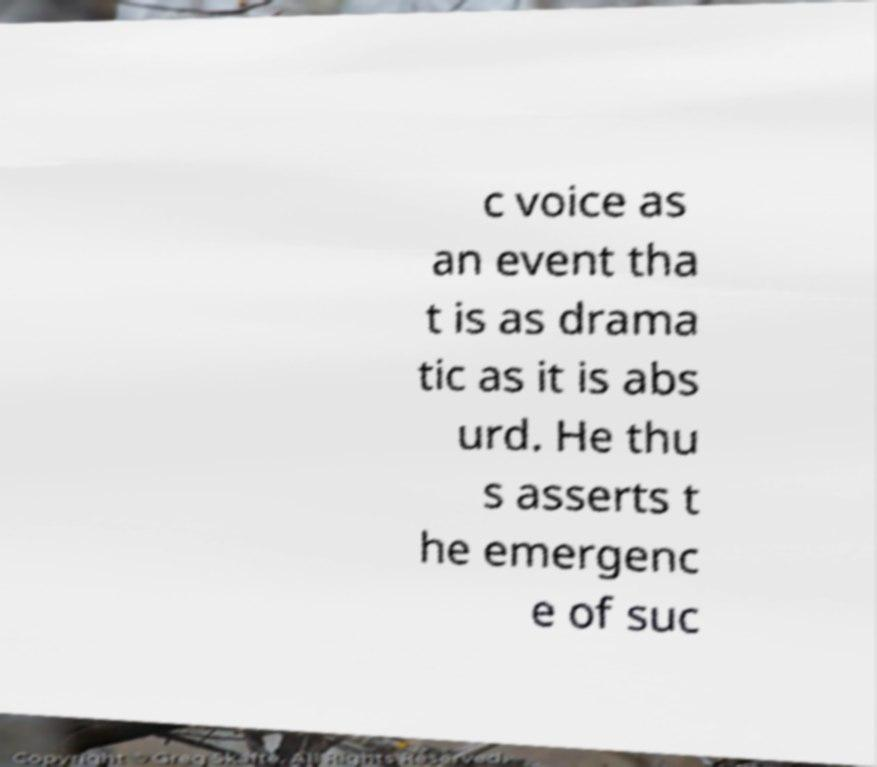Can you read and provide the text displayed in the image?This photo seems to have some interesting text. Can you extract and type it out for me? c voice as an event tha t is as drama tic as it is abs urd. He thu s asserts t he emergenc e of suc 